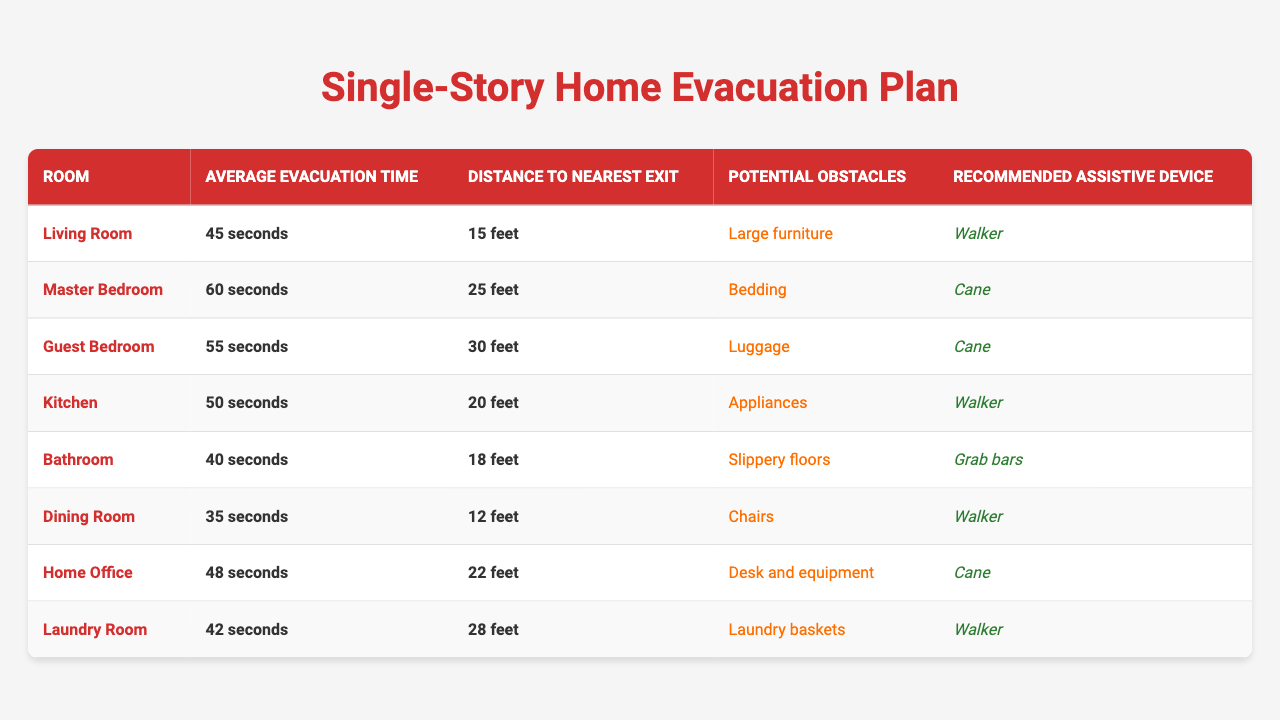What room has the fastest average evacuation time? The average evacuation times for each room are listed in the table. By comparing the values, the Dining Room has the fastest time of 35 seconds.
Answer: Dining Room Which room has the most significant potential obstacles? From the table, the room with the most substantial potential obstacles is the Kitchen, where appliances can impede evacuation.
Answer: Kitchen What is the average evacuation time from the Master Bedroom and the Kitchen? The evacuation times for the Master Bedroom and Kitchen are 60 seconds and 50 seconds, respectively. The average is calculated as (60 + 50) / 2 = 55 seconds.
Answer: 55 seconds Is it true that the Laundry Room requires more time to evacuate than the Home Office? The evacuation time for the Laundry Room is 42 seconds, while the Home Office has an evacuation time of 48 seconds. Thus, the statement is false.
Answer: No Which room has the furthest distance to the nearest exit and what is that distance? According to the table, the Guest Bedroom has the furthest distance to the nearest exit at 30 feet.
Answer: Guest Bedroom, 30 feet If a person uses a walker, which rooms can they efficiently evacuate from? The table shows that the Walker is recommended for the Living Room, Kitchen, Dining Room, and Laundry Room. Therefore, these rooms can be evacuated efficiently with a walker.
Answer: Living Room, Kitchen, Dining Room, Laundry Room What is the total evacuation time for all rooms combined? The evacuation times are: 45, 60, 55, 50, 40, 35, 48, and 42 seconds. Summing these gives 45 + 60 + 55 + 50 + 40 + 35 + 48 + 42 = 375 seconds.
Answer: 375 seconds Which room has the least distance to the nearest exit? From the table, the Dining Room has the least distance at 12 feet.
Answer: Dining Room, 12 feet What is the difference in evacuation time between the Master Bedroom and the Bathroom? The Master Bedroom takes 60 seconds, and the Bathroom takes 40 seconds. The difference is calculated as 60 - 40 = 20 seconds.
Answer: 20 seconds If a person takes 5 seconds longer than the average time to evacuate the Kitchen, what would that total time be? The average evacuation time for the Kitchen is 50 seconds. Adding 5 seconds gives a total of 50 + 5 = 55 seconds.
Answer: 55 seconds 